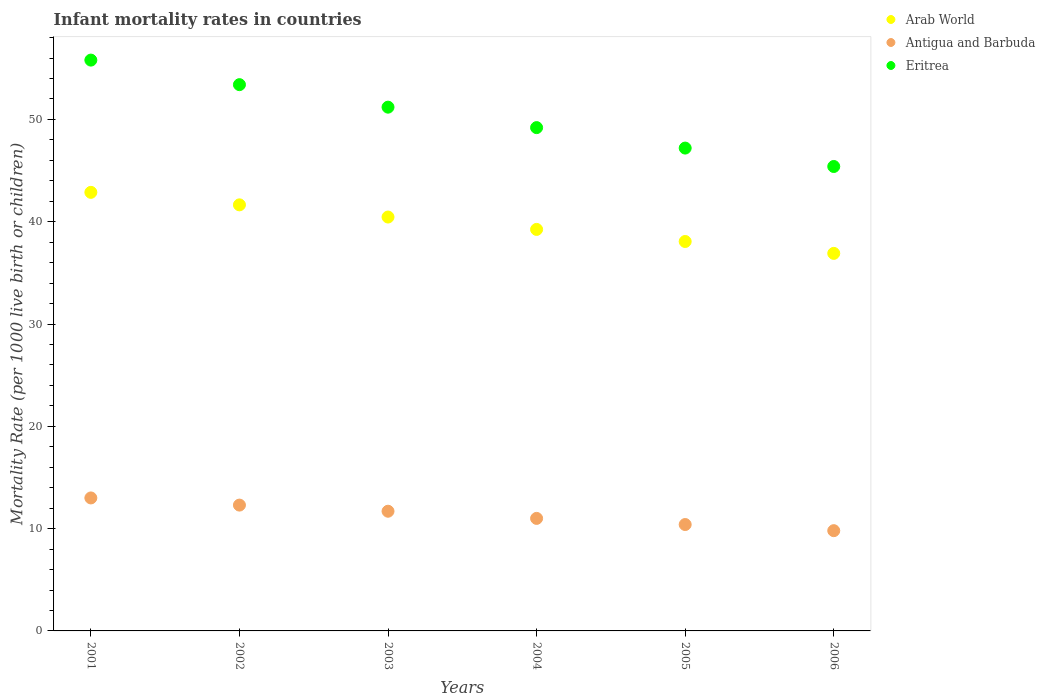What is the infant mortality rate in Eritrea in 2001?
Your answer should be compact. 55.8. Across all years, what is the maximum infant mortality rate in Eritrea?
Offer a terse response. 55.8. In which year was the infant mortality rate in Antigua and Barbuda maximum?
Your answer should be very brief. 2001. In which year was the infant mortality rate in Antigua and Barbuda minimum?
Offer a terse response. 2006. What is the total infant mortality rate in Eritrea in the graph?
Ensure brevity in your answer.  302.2. What is the difference between the infant mortality rate in Arab World in 2002 and that in 2004?
Your answer should be very brief. 2.4. What is the difference between the infant mortality rate in Arab World in 2002 and the infant mortality rate in Eritrea in 2001?
Give a very brief answer. -14.15. What is the average infant mortality rate in Arab World per year?
Your answer should be very brief. 39.87. In the year 2002, what is the difference between the infant mortality rate in Eritrea and infant mortality rate in Antigua and Barbuda?
Provide a short and direct response. 41.1. What is the ratio of the infant mortality rate in Eritrea in 2002 to that in 2006?
Your response must be concise. 1.18. Is the difference between the infant mortality rate in Eritrea in 2003 and 2006 greater than the difference between the infant mortality rate in Antigua and Barbuda in 2003 and 2006?
Ensure brevity in your answer.  Yes. What is the difference between the highest and the second highest infant mortality rate in Arab World?
Offer a terse response. 1.22. What is the difference between the highest and the lowest infant mortality rate in Arab World?
Keep it short and to the point. 5.97. In how many years, is the infant mortality rate in Antigua and Barbuda greater than the average infant mortality rate in Antigua and Barbuda taken over all years?
Your answer should be compact. 3. How many dotlines are there?
Offer a terse response. 3. What is the difference between two consecutive major ticks on the Y-axis?
Your answer should be compact. 10. Does the graph contain any zero values?
Your response must be concise. No. Does the graph contain grids?
Provide a short and direct response. No. Where does the legend appear in the graph?
Your answer should be compact. Top right. How many legend labels are there?
Offer a very short reply. 3. What is the title of the graph?
Offer a terse response. Infant mortality rates in countries. What is the label or title of the X-axis?
Provide a short and direct response. Years. What is the label or title of the Y-axis?
Your answer should be compact. Mortality Rate (per 1000 live birth or children). What is the Mortality Rate (per 1000 live birth or children) in Arab World in 2001?
Give a very brief answer. 42.87. What is the Mortality Rate (per 1000 live birth or children) in Antigua and Barbuda in 2001?
Keep it short and to the point. 13. What is the Mortality Rate (per 1000 live birth or children) in Eritrea in 2001?
Provide a short and direct response. 55.8. What is the Mortality Rate (per 1000 live birth or children) of Arab World in 2002?
Give a very brief answer. 41.65. What is the Mortality Rate (per 1000 live birth or children) in Antigua and Barbuda in 2002?
Ensure brevity in your answer.  12.3. What is the Mortality Rate (per 1000 live birth or children) of Eritrea in 2002?
Make the answer very short. 53.4. What is the Mortality Rate (per 1000 live birth or children) in Arab World in 2003?
Give a very brief answer. 40.46. What is the Mortality Rate (per 1000 live birth or children) of Antigua and Barbuda in 2003?
Provide a short and direct response. 11.7. What is the Mortality Rate (per 1000 live birth or children) of Eritrea in 2003?
Make the answer very short. 51.2. What is the Mortality Rate (per 1000 live birth or children) of Arab World in 2004?
Provide a succinct answer. 39.25. What is the Mortality Rate (per 1000 live birth or children) in Eritrea in 2004?
Ensure brevity in your answer.  49.2. What is the Mortality Rate (per 1000 live birth or children) of Arab World in 2005?
Ensure brevity in your answer.  38.07. What is the Mortality Rate (per 1000 live birth or children) in Antigua and Barbuda in 2005?
Keep it short and to the point. 10.4. What is the Mortality Rate (per 1000 live birth or children) of Eritrea in 2005?
Ensure brevity in your answer.  47.2. What is the Mortality Rate (per 1000 live birth or children) of Arab World in 2006?
Your answer should be compact. 36.91. What is the Mortality Rate (per 1000 live birth or children) of Eritrea in 2006?
Provide a short and direct response. 45.4. Across all years, what is the maximum Mortality Rate (per 1000 live birth or children) in Arab World?
Your answer should be very brief. 42.87. Across all years, what is the maximum Mortality Rate (per 1000 live birth or children) of Antigua and Barbuda?
Your response must be concise. 13. Across all years, what is the maximum Mortality Rate (per 1000 live birth or children) in Eritrea?
Offer a terse response. 55.8. Across all years, what is the minimum Mortality Rate (per 1000 live birth or children) of Arab World?
Keep it short and to the point. 36.91. Across all years, what is the minimum Mortality Rate (per 1000 live birth or children) of Eritrea?
Provide a short and direct response. 45.4. What is the total Mortality Rate (per 1000 live birth or children) in Arab World in the graph?
Provide a succinct answer. 239.21. What is the total Mortality Rate (per 1000 live birth or children) in Antigua and Barbuda in the graph?
Make the answer very short. 68.2. What is the total Mortality Rate (per 1000 live birth or children) in Eritrea in the graph?
Provide a succinct answer. 302.2. What is the difference between the Mortality Rate (per 1000 live birth or children) in Arab World in 2001 and that in 2002?
Your answer should be very brief. 1.22. What is the difference between the Mortality Rate (per 1000 live birth or children) of Antigua and Barbuda in 2001 and that in 2002?
Offer a very short reply. 0.7. What is the difference between the Mortality Rate (per 1000 live birth or children) of Arab World in 2001 and that in 2003?
Your response must be concise. 2.41. What is the difference between the Mortality Rate (per 1000 live birth or children) of Antigua and Barbuda in 2001 and that in 2003?
Ensure brevity in your answer.  1.3. What is the difference between the Mortality Rate (per 1000 live birth or children) of Eritrea in 2001 and that in 2003?
Give a very brief answer. 4.6. What is the difference between the Mortality Rate (per 1000 live birth or children) of Arab World in 2001 and that in 2004?
Offer a terse response. 3.62. What is the difference between the Mortality Rate (per 1000 live birth or children) in Arab World in 2001 and that in 2005?
Ensure brevity in your answer.  4.8. What is the difference between the Mortality Rate (per 1000 live birth or children) of Antigua and Barbuda in 2001 and that in 2005?
Provide a succinct answer. 2.6. What is the difference between the Mortality Rate (per 1000 live birth or children) of Eritrea in 2001 and that in 2005?
Make the answer very short. 8.6. What is the difference between the Mortality Rate (per 1000 live birth or children) in Arab World in 2001 and that in 2006?
Your response must be concise. 5.97. What is the difference between the Mortality Rate (per 1000 live birth or children) of Antigua and Barbuda in 2001 and that in 2006?
Your answer should be compact. 3.2. What is the difference between the Mortality Rate (per 1000 live birth or children) of Arab World in 2002 and that in 2003?
Keep it short and to the point. 1.19. What is the difference between the Mortality Rate (per 1000 live birth or children) in Antigua and Barbuda in 2002 and that in 2003?
Your response must be concise. 0.6. What is the difference between the Mortality Rate (per 1000 live birth or children) of Arab World in 2002 and that in 2004?
Provide a succinct answer. 2.4. What is the difference between the Mortality Rate (per 1000 live birth or children) in Antigua and Barbuda in 2002 and that in 2004?
Offer a terse response. 1.3. What is the difference between the Mortality Rate (per 1000 live birth or children) of Eritrea in 2002 and that in 2004?
Provide a succinct answer. 4.2. What is the difference between the Mortality Rate (per 1000 live birth or children) of Arab World in 2002 and that in 2005?
Your answer should be compact. 3.58. What is the difference between the Mortality Rate (per 1000 live birth or children) of Arab World in 2002 and that in 2006?
Your answer should be compact. 4.74. What is the difference between the Mortality Rate (per 1000 live birth or children) of Antigua and Barbuda in 2002 and that in 2006?
Your answer should be compact. 2.5. What is the difference between the Mortality Rate (per 1000 live birth or children) in Arab World in 2003 and that in 2004?
Your answer should be very brief. 1.21. What is the difference between the Mortality Rate (per 1000 live birth or children) in Arab World in 2003 and that in 2005?
Your answer should be compact. 2.39. What is the difference between the Mortality Rate (per 1000 live birth or children) of Antigua and Barbuda in 2003 and that in 2005?
Your response must be concise. 1.3. What is the difference between the Mortality Rate (per 1000 live birth or children) of Eritrea in 2003 and that in 2005?
Give a very brief answer. 4. What is the difference between the Mortality Rate (per 1000 live birth or children) in Arab World in 2003 and that in 2006?
Ensure brevity in your answer.  3.55. What is the difference between the Mortality Rate (per 1000 live birth or children) in Antigua and Barbuda in 2003 and that in 2006?
Your answer should be very brief. 1.9. What is the difference between the Mortality Rate (per 1000 live birth or children) of Eritrea in 2003 and that in 2006?
Your answer should be compact. 5.8. What is the difference between the Mortality Rate (per 1000 live birth or children) of Arab World in 2004 and that in 2005?
Make the answer very short. 1.18. What is the difference between the Mortality Rate (per 1000 live birth or children) in Eritrea in 2004 and that in 2005?
Your response must be concise. 2. What is the difference between the Mortality Rate (per 1000 live birth or children) of Arab World in 2004 and that in 2006?
Your answer should be very brief. 2.34. What is the difference between the Mortality Rate (per 1000 live birth or children) of Antigua and Barbuda in 2004 and that in 2006?
Give a very brief answer. 1.2. What is the difference between the Mortality Rate (per 1000 live birth or children) in Eritrea in 2004 and that in 2006?
Your answer should be very brief. 3.8. What is the difference between the Mortality Rate (per 1000 live birth or children) of Arab World in 2005 and that in 2006?
Offer a very short reply. 1.16. What is the difference between the Mortality Rate (per 1000 live birth or children) of Arab World in 2001 and the Mortality Rate (per 1000 live birth or children) of Antigua and Barbuda in 2002?
Keep it short and to the point. 30.57. What is the difference between the Mortality Rate (per 1000 live birth or children) of Arab World in 2001 and the Mortality Rate (per 1000 live birth or children) of Eritrea in 2002?
Offer a terse response. -10.53. What is the difference between the Mortality Rate (per 1000 live birth or children) in Antigua and Barbuda in 2001 and the Mortality Rate (per 1000 live birth or children) in Eritrea in 2002?
Offer a very short reply. -40.4. What is the difference between the Mortality Rate (per 1000 live birth or children) in Arab World in 2001 and the Mortality Rate (per 1000 live birth or children) in Antigua and Barbuda in 2003?
Give a very brief answer. 31.17. What is the difference between the Mortality Rate (per 1000 live birth or children) of Arab World in 2001 and the Mortality Rate (per 1000 live birth or children) of Eritrea in 2003?
Your response must be concise. -8.33. What is the difference between the Mortality Rate (per 1000 live birth or children) of Antigua and Barbuda in 2001 and the Mortality Rate (per 1000 live birth or children) of Eritrea in 2003?
Provide a short and direct response. -38.2. What is the difference between the Mortality Rate (per 1000 live birth or children) in Arab World in 2001 and the Mortality Rate (per 1000 live birth or children) in Antigua and Barbuda in 2004?
Your answer should be very brief. 31.87. What is the difference between the Mortality Rate (per 1000 live birth or children) in Arab World in 2001 and the Mortality Rate (per 1000 live birth or children) in Eritrea in 2004?
Keep it short and to the point. -6.33. What is the difference between the Mortality Rate (per 1000 live birth or children) of Antigua and Barbuda in 2001 and the Mortality Rate (per 1000 live birth or children) of Eritrea in 2004?
Your answer should be very brief. -36.2. What is the difference between the Mortality Rate (per 1000 live birth or children) of Arab World in 2001 and the Mortality Rate (per 1000 live birth or children) of Antigua and Barbuda in 2005?
Provide a short and direct response. 32.47. What is the difference between the Mortality Rate (per 1000 live birth or children) in Arab World in 2001 and the Mortality Rate (per 1000 live birth or children) in Eritrea in 2005?
Offer a very short reply. -4.33. What is the difference between the Mortality Rate (per 1000 live birth or children) in Antigua and Barbuda in 2001 and the Mortality Rate (per 1000 live birth or children) in Eritrea in 2005?
Offer a terse response. -34.2. What is the difference between the Mortality Rate (per 1000 live birth or children) of Arab World in 2001 and the Mortality Rate (per 1000 live birth or children) of Antigua and Barbuda in 2006?
Keep it short and to the point. 33.07. What is the difference between the Mortality Rate (per 1000 live birth or children) in Arab World in 2001 and the Mortality Rate (per 1000 live birth or children) in Eritrea in 2006?
Make the answer very short. -2.53. What is the difference between the Mortality Rate (per 1000 live birth or children) of Antigua and Barbuda in 2001 and the Mortality Rate (per 1000 live birth or children) of Eritrea in 2006?
Your answer should be compact. -32.4. What is the difference between the Mortality Rate (per 1000 live birth or children) in Arab World in 2002 and the Mortality Rate (per 1000 live birth or children) in Antigua and Barbuda in 2003?
Your answer should be very brief. 29.95. What is the difference between the Mortality Rate (per 1000 live birth or children) in Arab World in 2002 and the Mortality Rate (per 1000 live birth or children) in Eritrea in 2003?
Provide a short and direct response. -9.55. What is the difference between the Mortality Rate (per 1000 live birth or children) in Antigua and Barbuda in 2002 and the Mortality Rate (per 1000 live birth or children) in Eritrea in 2003?
Ensure brevity in your answer.  -38.9. What is the difference between the Mortality Rate (per 1000 live birth or children) of Arab World in 2002 and the Mortality Rate (per 1000 live birth or children) of Antigua and Barbuda in 2004?
Make the answer very short. 30.65. What is the difference between the Mortality Rate (per 1000 live birth or children) of Arab World in 2002 and the Mortality Rate (per 1000 live birth or children) of Eritrea in 2004?
Your answer should be compact. -7.55. What is the difference between the Mortality Rate (per 1000 live birth or children) in Antigua and Barbuda in 2002 and the Mortality Rate (per 1000 live birth or children) in Eritrea in 2004?
Your answer should be compact. -36.9. What is the difference between the Mortality Rate (per 1000 live birth or children) in Arab World in 2002 and the Mortality Rate (per 1000 live birth or children) in Antigua and Barbuda in 2005?
Offer a terse response. 31.25. What is the difference between the Mortality Rate (per 1000 live birth or children) in Arab World in 2002 and the Mortality Rate (per 1000 live birth or children) in Eritrea in 2005?
Ensure brevity in your answer.  -5.55. What is the difference between the Mortality Rate (per 1000 live birth or children) of Antigua and Barbuda in 2002 and the Mortality Rate (per 1000 live birth or children) of Eritrea in 2005?
Your answer should be very brief. -34.9. What is the difference between the Mortality Rate (per 1000 live birth or children) of Arab World in 2002 and the Mortality Rate (per 1000 live birth or children) of Antigua and Barbuda in 2006?
Make the answer very short. 31.85. What is the difference between the Mortality Rate (per 1000 live birth or children) in Arab World in 2002 and the Mortality Rate (per 1000 live birth or children) in Eritrea in 2006?
Provide a succinct answer. -3.75. What is the difference between the Mortality Rate (per 1000 live birth or children) of Antigua and Barbuda in 2002 and the Mortality Rate (per 1000 live birth or children) of Eritrea in 2006?
Your response must be concise. -33.1. What is the difference between the Mortality Rate (per 1000 live birth or children) in Arab World in 2003 and the Mortality Rate (per 1000 live birth or children) in Antigua and Barbuda in 2004?
Provide a succinct answer. 29.46. What is the difference between the Mortality Rate (per 1000 live birth or children) of Arab World in 2003 and the Mortality Rate (per 1000 live birth or children) of Eritrea in 2004?
Your response must be concise. -8.74. What is the difference between the Mortality Rate (per 1000 live birth or children) of Antigua and Barbuda in 2003 and the Mortality Rate (per 1000 live birth or children) of Eritrea in 2004?
Give a very brief answer. -37.5. What is the difference between the Mortality Rate (per 1000 live birth or children) of Arab World in 2003 and the Mortality Rate (per 1000 live birth or children) of Antigua and Barbuda in 2005?
Your answer should be very brief. 30.06. What is the difference between the Mortality Rate (per 1000 live birth or children) in Arab World in 2003 and the Mortality Rate (per 1000 live birth or children) in Eritrea in 2005?
Offer a very short reply. -6.74. What is the difference between the Mortality Rate (per 1000 live birth or children) of Antigua and Barbuda in 2003 and the Mortality Rate (per 1000 live birth or children) of Eritrea in 2005?
Offer a very short reply. -35.5. What is the difference between the Mortality Rate (per 1000 live birth or children) in Arab World in 2003 and the Mortality Rate (per 1000 live birth or children) in Antigua and Barbuda in 2006?
Offer a very short reply. 30.66. What is the difference between the Mortality Rate (per 1000 live birth or children) in Arab World in 2003 and the Mortality Rate (per 1000 live birth or children) in Eritrea in 2006?
Make the answer very short. -4.94. What is the difference between the Mortality Rate (per 1000 live birth or children) of Antigua and Barbuda in 2003 and the Mortality Rate (per 1000 live birth or children) of Eritrea in 2006?
Your response must be concise. -33.7. What is the difference between the Mortality Rate (per 1000 live birth or children) of Arab World in 2004 and the Mortality Rate (per 1000 live birth or children) of Antigua and Barbuda in 2005?
Give a very brief answer. 28.85. What is the difference between the Mortality Rate (per 1000 live birth or children) in Arab World in 2004 and the Mortality Rate (per 1000 live birth or children) in Eritrea in 2005?
Provide a succinct answer. -7.95. What is the difference between the Mortality Rate (per 1000 live birth or children) in Antigua and Barbuda in 2004 and the Mortality Rate (per 1000 live birth or children) in Eritrea in 2005?
Offer a terse response. -36.2. What is the difference between the Mortality Rate (per 1000 live birth or children) of Arab World in 2004 and the Mortality Rate (per 1000 live birth or children) of Antigua and Barbuda in 2006?
Provide a succinct answer. 29.45. What is the difference between the Mortality Rate (per 1000 live birth or children) of Arab World in 2004 and the Mortality Rate (per 1000 live birth or children) of Eritrea in 2006?
Offer a very short reply. -6.15. What is the difference between the Mortality Rate (per 1000 live birth or children) in Antigua and Barbuda in 2004 and the Mortality Rate (per 1000 live birth or children) in Eritrea in 2006?
Give a very brief answer. -34.4. What is the difference between the Mortality Rate (per 1000 live birth or children) of Arab World in 2005 and the Mortality Rate (per 1000 live birth or children) of Antigua and Barbuda in 2006?
Your answer should be compact. 28.27. What is the difference between the Mortality Rate (per 1000 live birth or children) in Arab World in 2005 and the Mortality Rate (per 1000 live birth or children) in Eritrea in 2006?
Your response must be concise. -7.33. What is the difference between the Mortality Rate (per 1000 live birth or children) of Antigua and Barbuda in 2005 and the Mortality Rate (per 1000 live birth or children) of Eritrea in 2006?
Offer a terse response. -35. What is the average Mortality Rate (per 1000 live birth or children) in Arab World per year?
Provide a short and direct response. 39.87. What is the average Mortality Rate (per 1000 live birth or children) of Antigua and Barbuda per year?
Your answer should be very brief. 11.37. What is the average Mortality Rate (per 1000 live birth or children) in Eritrea per year?
Give a very brief answer. 50.37. In the year 2001, what is the difference between the Mortality Rate (per 1000 live birth or children) in Arab World and Mortality Rate (per 1000 live birth or children) in Antigua and Barbuda?
Your answer should be compact. 29.87. In the year 2001, what is the difference between the Mortality Rate (per 1000 live birth or children) of Arab World and Mortality Rate (per 1000 live birth or children) of Eritrea?
Your answer should be very brief. -12.93. In the year 2001, what is the difference between the Mortality Rate (per 1000 live birth or children) of Antigua and Barbuda and Mortality Rate (per 1000 live birth or children) of Eritrea?
Offer a very short reply. -42.8. In the year 2002, what is the difference between the Mortality Rate (per 1000 live birth or children) in Arab World and Mortality Rate (per 1000 live birth or children) in Antigua and Barbuda?
Your answer should be very brief. 29.35. In the year 2002, what is the difference between the Mortality Rate (per 1000 live birth or children) in Arab World and Mortality Rate (per 1000 live birth or children) in Eritrea?
Your answer should be compact. -11.75. In the year 2002, what is the difference between the Mortality Rate (per 1000 live birth or children) of Antigua and Barbuda and Mortality Rate (per 1000 live birth or children) of Eritrea?
Offer a terse response. -41.1. In the year 2003, what is the difference between the Mortality Rate (per 1000 live birth or children) in Arab World and Mortality Rate (per 1000 live birth or children) in Antigua and Barbuda?
Ensure brevity in your answer.  28.76. In the year 2003, what is the difference between the Mortality Rate (per 1000 live birth or children) of Arab World and Mortality Rate (per 1000 live birth or children) of Eritrea?
Give a very brief answer. -10.74. In the year 2003, what is the difference between the Mortality Rate (per 1000 live birth or children) in Antigua and Barbuda and Mortality Rate (per 1000 live birth or children) in Eritrea?
Your answer should be compact. -39.5. In the year 2004, what is the difference between the Mortality Rate (per 1000 live birth or children) of Arab World and Mortality Rate (per 1000 live birth or children) of Antigua and Barbuda?
Provide a short and direct response. 28.25. In the year 2004, what is the difference between the Mortality Rate (per 1000 live birth or children) of Arab World and Mortality Rate (per 1000 live birth or children) of Eritrea?
Ensure brevity in your answer.  -9.95. In the year 2004, what is the difference between the Mortality Rate (per 1000 live birth or children) in Antigua and Barbuda and Mortality Rate (per 1000 live birth or children) in Eritrea?
Your answer should be very brief. -38.2. In the year 2005, what is the difference between the Mortality Rate (per 1000 live birth or children) of Arab World and Mortality Rate (per 1000 live birth or children) of Antigua and Barbuda?
Keep it short and to the point. 27.67. In the year 2005, what is the difference between the Mortality Rate (per 1000 live birth or children) of Arab World and Mortality Rate (per 1000 live birth or children) of Eritrea?
Offer a very short reply. -9.13. In the year 2005, what is the difference between the Mortality Rate (per 1000 live birth or children) of Antigua and Barbuda and Mortality Rate (per 1000 live birth or children) of Eritrea?
Keep it short and to the point. -36.8. In the year 2006, what is the difference between the Mortality Rate (per 1000 live birth or children) in Arab World and Mortality Rate (per 1000 live birth or children) in Antigua and Barbuda?
Your response must be concise. 27.11. In the year 2006, what is the difference between the Mortality Rate (per 1000 live birth or children) of Arab World and Mortality Rate (per 1000 live birth or children) of Eritrea?
Offer a very short reply. -8.49. In the year 2006, what is the difference between the Mortality Rate (per 1000 live birth or children) in Antigua and Barbuda and Mortality Rate (per 1000 live birth or children) in Eritrea?
Your answer should be very brief. -35.6. What is the ratio of the Mortality Rate (per 1000 live birth or children) of Arab World in 2001 to that in 2002?
Ensure brevity in your answer.  1.03. What is the ratio of the Mortality Rate (per 1000 live birth or children) of Antigua and Barbuda in 2001 to that in 2002?
Ensure brevity in your answer.  1.06. What is the ratio of the Mortality Rate (per 1000 live birth or children) in Eritrea in 2001 to that in 2002?
Provide a succinct answer. 1.04. What is the ratio of the Mortality Rate (per 1000 live birth or children) in Arab World in 2001 to that in 2003?
Offer a very short reply. 1.06. What is the ratio of the Mortality Rate (per 1000 live birth or children) of Eritrea in 2001 to that in 2003?
Your answer should be compact. 1.09. What is the ratio of the Mortality Rate (per 1000 live birth or children) of Arab World in 2001 to that in 2004?
Provide a succinct answer. 1.09. What is the ratio of the Mortality Rate (per 1000 live birth or children) of Antigua and Barbuda in 2001 to that in 2004?
Your response must be concise. 1.18. What is the ratio of the Mortality Rate (per 1000 live birth or children) of Eritrea in 2001 to that in 2004?
Your response must be concise. 1.13. What is the ratio of the Mortality Rate (per 1000 live birth or children) in Arab World in 2001 to that in 2005?
Your answer should be compact. 1.13. What is the ratio of the Mortality Rate (per 1000 live birth or children) of Antigua and Barbuda in 2001 to that in 2005?
Your answer should be compact. 1.25. What is the ratio of the Mortality Rate (per 1000 live birth or children) in Eritrea in 2001 to that in 2005?
Make the answer very short. 1.18. What is the ratio of the Mortality Rate (per 1000 live birth or children) in Arab World in 2001 to that in 2006?
Offer a terse response. 1.16. What is the ratio of the Mortality Rate (per 1000 live birth or children) in Antigua and Barbuda in 2001 to that in 2006?
Your response must be concise. 1.33. What is the ratio of the Mortality Rate (per 1000 live birth or children) in Eritrea in 2001 to that in 2006?
Offer a very short reply. 1.23. What is the ratio of the Mortality Rate (per 1000 live birth or children) in Arab World in 2002 to that in 2003?
Your answer should be compact. 1.03. What is the ratio of the Mortality Rate (per 1000 live birth or children) of Antigua and Barbuda in 2002 to that in 2003?
Your response must be concise. 1.05. What is the ratio of the Mortality Rate (per 1000 live birth or children) in Eritrea in 2002 to that in 2003?
Ensure brevity in your answer.  1.04. What is the ratio of the Mortality Rate (per 1000 live birth or children) of Arab World in 2002 to that in 2004?
Offer a very short reply. 1.06. What is the ratio of the Mortality Rate (per 1000 live birth or children) of Antigua and Barbuda in 2002 to that in 2004?
Ensure brevity in your answer.  1.12. What is the ratio of the Mortality Rate (per 1000 live birth or children) of Eritrea in 2002 to that in 2004?
Your answer should be compact. 1.09. What is the ratio of the Mortality Rate (per 1000 live birth or children) of Arab World in 2002 to that in 2005?
Your response must be concise. 1.09. What is the ratio of the Mortality Rate (per 1000 live birth or children) of Antigua and Barbuda in 2002 to that in 2005?
Offer a terse response. 1.18. What is the ratio of the Mortality Rate (per 1000 live birth or children) of Eritrea in 2002 to that in 2005?
Keep it short and to the point. 1.13. What is the ratio of the Mortality Rate (per 1000 live birth or children) in Arab World in 2002 to that in 2006?
Keep it short and to the point. 1.13. What is the ratio of the Mortality Rate (per 1000 live birth or children) of Antigua and Barbuda in 2002 to that in 2006?
Your answer should be very brief. 1.26. What is the ratio of the Mortality Rate (per 1000 live birth or children) of Eritrea in 2002 to that in 2006?
Your response must be concise. 1.18. What is the ratio of the Mortality Rate (per 1000 live birth or children) in Arab World in 2003 to that in 2004?
Your response must be concise. 1.03. What is the ratio of the Mortality Rate (per 1000 live birth or children) in Antigua and Barbuda in 2003 to that in 2004?
Offer a very short reply. 1.06. What is the ratio of the Mortality Rate (per 1000 live birth or children) in Eritrea in 2003 to that in 2004?
Offer a very short reply. 1.04. What is the ratio of the Mortality Rate (per 1000 live birth or children) in Arab World in 2003 to that in 2005?
Your answer should be very brief. 1.06. What is the ratio of the Mortality Rate (per 1000 live birth or children) in Eritrea in 2003 to that in 2005?
Make the answer very short. 1.08. What is the ratio of the Mortality Rate (per 1000 live birth or children) in Arab World in 2003 to that in 2006?
Make the answer very short. 1.1. What is the ratio of the Mortality Rate (per 1000 live birth or children) of Antigua and Barbuda in 2003 to that in 2006?
Provide a short and direct response. 1.19. What is the ratio of the Mortality Rate (per 1000 live birth or children) in Eritrea in 2003 to that in 2006?
Give a very brief answer. 1.13. What is the ratio of the Mortality Rate (per 1000 live birth or children) in Arab World in 2004 to that in 2005?
Keep it short and to the point. 1.03. What is the ratio of the Mortality Rate (per 1000 live birth or children) of Antigua and Barbuda in 2004 to that in 2005?
Make the answer very short. 1.06. What is the ratio of the Mortality Rate (per 1000 live birth or children) of Eritrea in 2004 to that in 2005?
Make the answer very short. 1.04. What is the ratio of the Mortality Rate (per 1000 live birth or children) in Arab World in 2004 to that in 2006?
Make the answer very short. 1.06. What is the ratio of the Mortality Rate (per 1000 live birth or children) in Antigua and Barbuda in 2004 to that in 2006?
Your answer should be very brief. 1.12. What is the ratio of the Mortality Rate (per 1000 live birth or children) in Eritrea in 2004 to that in 2006?
Give a very brief answer. 1.08. What is the ratio of the Mortality Rate (per 1000 live birth or children) of Arab World in 2005 to that in 2006?
Ensure brevity in your answer.  1.03. What is the ratio of the Mortality Rate (per 1000 live birth or children) in Antigua and Barbuda in 2005 to that in 2006?
Provide a succinct answer. 1.06. What is the ratio of the Mortality Rate (per 1000 live birth or children) in Eritrea in 2005 to that in 2006?
Your answer should be very brief. 1.04. What is the difference between the highest and the second highest Mortality Rate (per 1000 live birth or children) in Arab World?
Ensure brevity in your answer.  1.22. What is the difference between the highest and the second highest Mortality Rate (per 1000 live birth or children) in Antigua and Barbuda?
Keep it short and to the point. 0.7. What is the difference between the highest and the second highest Mortality Rate (per 1000 live birth or children) of Eritrea?
Your answer should be very brief. 2.4. What is the difference between the highest and the lowest Mortality Rate (per 1000 live birth or children) of Arab World?
Keep it short and to the point. 5.97. What is the difference between the highest and the lowest Mortality Rate (per 1000 live birth or children) in Eritrea?
Keep it short and to the point. 10.4. 